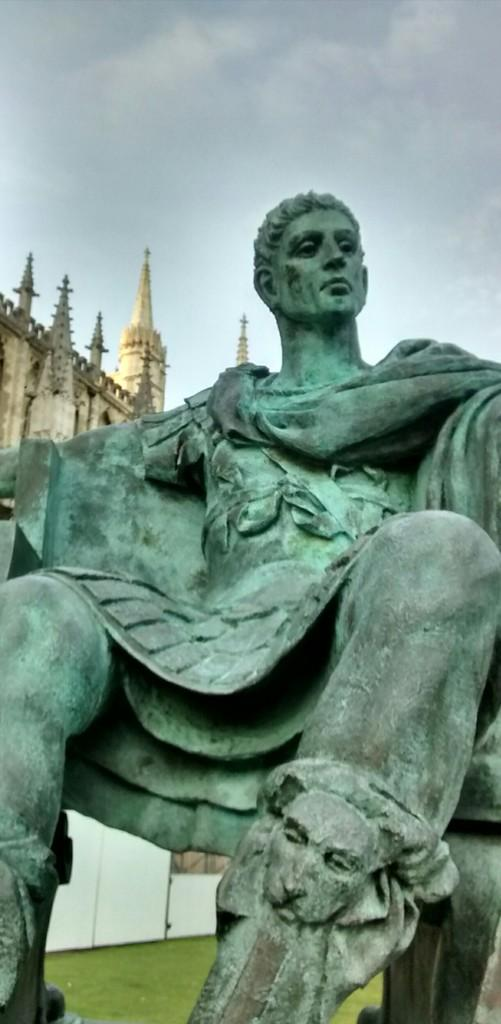What is the main subject in the image? There is a statue in the image. What type of natural environment is visible in the image? There is grass visible in the image. What type of structure can be seen in the image? There is a building in the image. What is the condition of the sky in the image? The sky is cloudy in the image. Can you see a locket hanging from the statue in the image? There is no locket visible on the statue in the image. Why is the statue crying in the image? The statue is not crying in the image; it is a stationary object. 